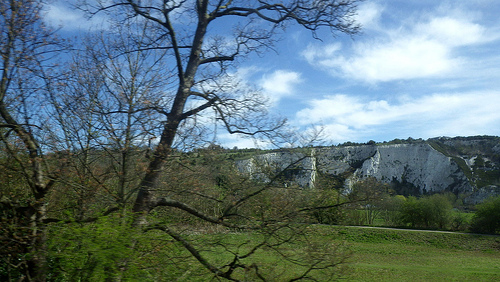<image>
Is the sky behind the tree? Yes. From this viewpoint, the sky is positioned behind the tree, with the tree partially or fully occluding the sky. 